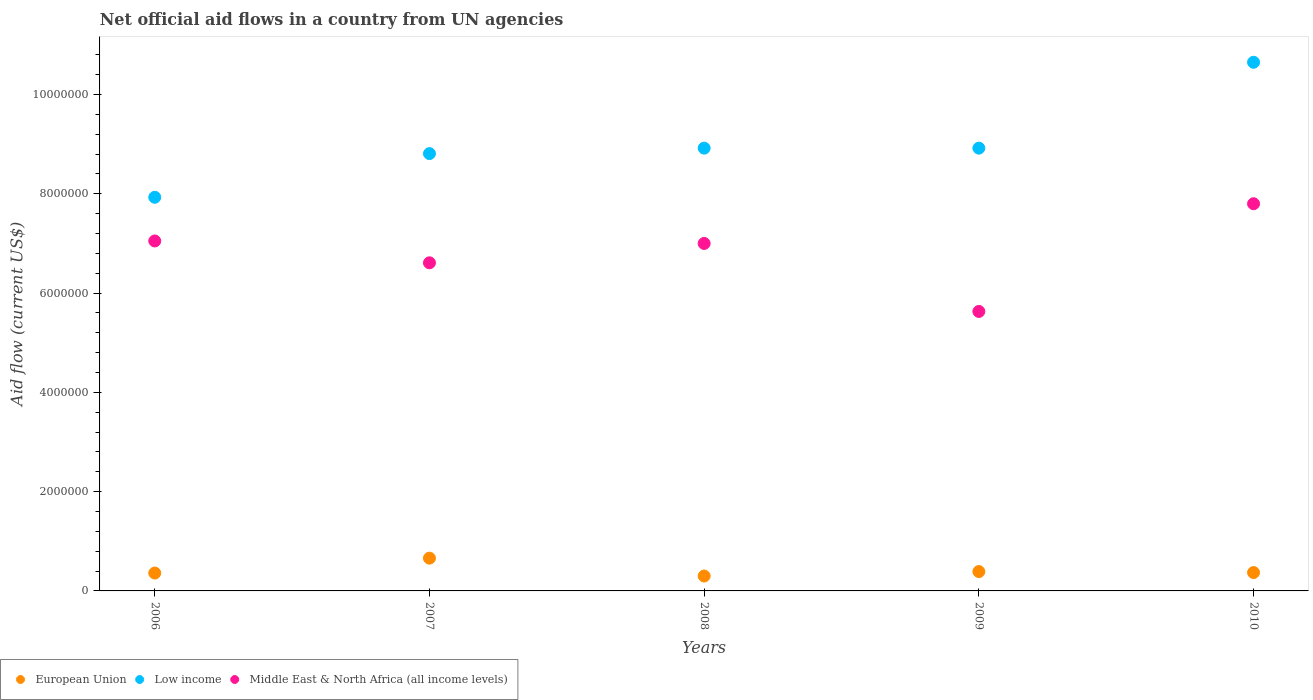How many different coloured dotlines are there?
Provide a short and direct response. 3. What is the net official aid flow in European Union in 2008?
Your answer should be very brief. 3.00e+05. Across all years, what is the minimum net official aid flow in Middle East & North Africa (all income levels)?
Offer a terse response. 5.63e+06. In which year was the net official aid flow in European Union minimum?
Your response must be concise. 2008. What is the total net official aid flow in Middle East & North Africa (all income levels) in the graph?
Give a very brief answer. 3.41e+07. What is the difference between the net official aid flow in Middle East & North Africa (all income levels) in 2006 and that in 2009?
Ensure brevity in your answer.  1.42e+06. What is the difference between the net official aid flow in Middle East & North Africa (all income levels) in 2006 and the net official aid flow in European Union in 2009?
Offer a terse response. 6.66e+06. What is the average net official aid flow in European Union per year?
Ensure brevity in your answer.  4.16e+05. In the year 2007, what is the difference between the net official aid flow in Low income and net official aid flow in Middle East & North Africa (all income levels)?
Make the answer very short. 2.20e+06. In how many years, is the net official aid flow in Low income greater than 6400000 US$?
Your response must be concise. 5. What is the ratio of the net official aid flow in Middle East & North Africa (all income levels) in 2007 to that in 2009?
Ensure brevity in your answer.  1.17. Is the net official aid flow in European Union in 2006 less than that in 2007?
Provide a succinct answer. Yes. Is the difference between the net official aid flow in Low income in 2009 and 2010 greater than the difference between the net official aid flow in Middle East & North Africa (all income levels) in 2009 and 2010?
Keep it short and to the point. Yes. What is the difference between the highest and the second highest net official aid flow in Low income?
Your answer should be very brief. 1.73e+06. What is the difference between the highest and the lowest net official aid flow in Middle East & North Africa (all income levels)?
Provide a short and direct response. 2.17e+06. Is the sum of the net official aid flow in Low income in 2006 and 2007 greater than the maximum net official aid flow in Middle East & North Africa (all income levels) across all years?
Offer a terse response. Yes. Is the net official aid flow in Middle East & North Africa (all income levels) strictly greater than the net official aid flow in Low income over the years?
Keep it short and to the point. No. How many years are there in the graph?
Offer a terse response. 5. Are the values on the major ticks of Y-axis written in scientific E-notation?
Provide a succinct answer. No. Does the graph contain any zero values?
Give a very brief answer. No. Does the graph contain grids?
Keep it short and to the point. No. How many legend labels are there?
Ensure brevity in your answer.  3. How are the legend labels stacked?
Offer a terse response. Horizontal. What is the title of the graph?
Your answer should be very brief. Net official aid flows in a country from UN agencies. What is the Aid flow (current US$) in European Union in 2006?
Provide a short and direct response. 3.60e+05. What is the Aid flow (current US$) of Low income in 2006?
Give a very brief answer. 7.93e+06. What is the Aid flow (current US$) of Middle East & North Africa (all income levels) in 2006?
Provide a succinct answer. 7.05e+06. What is the Aid flow (current US$) of European Union in 2007?
Provide a succinct answer. 6.60e+05. What is the Aid flow (current US$) of Low income in 2007?
Your response must be concise. 8.81e+06. What is the Aid flow (current US$) of Middle East & North Africa (all income levels) in 2007?
Your response must be concise. 6.61e+06. What is the Aid flow (current US$) of European Union in 2008?
Your answer should be very brief. 3.00e+05. What is the Aid flow (current US$) of Low income in 2008?
Offer a terse response. 8.92e+06. What is the Aid flow (current US$) of Low income in 2009?
Your answer should be very brief. 8.92e+06. What is the Aid flow (current US$) in Middle East & North Africa (all income levels) in 2009?
Offer a very short reply. 5.63e+06. What is the Aid flow (current US$) in European Union in 2010?
Offer a very short reply. 3.70e+05. What is the Aid flow (current US$) in Low income in 2010?
Give a very brief answer. 1.06e+07. What is the Aid flow (current US$) in Middle East & North Africa (all income levels) in 2010?
Give a very brief answer. 7.80e+06. Across all years, what is the maximum Aid flow (current US$) in Low income?
Keep it short and to the point. 1.06e+07. Across all years, what is the maximum Aid flow (current US$) of Middle East & North Africa (all income levels)?
Keep it short and to the point. 7.80e+06. Across all years, what is the minimum Aid flow (current US$) of European Union?
Offer a very short reply. 3.00e+05. Across all years, what is the minimum Aid flow (current US$) in Low income?
Your answer should be very brief. 7.93e+06. Across all years, what is the minimum Aid flow (current US$) in Middle East & North Africa (all income levels)?
Your response must be concise. 5.63e+06. What is the total Aid flow (current US$) in European Union in the graph?
Your response must be concise. 2.08e+06. What is the total Aid flow (current US$) in Low income in the graph?
Keep it short and to the point. 4.52e+07. What is the total Aid flow (current US$) of Middle East & North Africa (all income levels) in the graph?
Make the answer very short. 3.41e+07. What is the difference between the Aid flow (current US$) of Low income in 2006 and that in 2007?
Give a very brief answer. -8.80e+05. What is the difference between the Aid flow (current US$) in Middle East & North Africa (all income levels) in 2006 and that in 2007?
Provide a short and direct response. 4.40e+05. What is the difference between the Aid flow (current US$) in European Union in 2006 and that in 2008?
Offer a very short reply. 6.00e+04. What is the difference between the Aid flow (current US$) in Low income in 2006 and that in 2008?
Your response must be concise. -9.90e+05. What is the difference between the Aid flow (current US$) of Middle East & North Africa (all income levels) in 2006 and that in 2008?
Offer a very short reply. 5.00e+04. What is the difference between the Aid flow (current US$) of Low income in 2006 and that in 2009?
Your answer should be compact. -9.90e+05. What is the difference between the Aid flow (current US$) of Middle East & North Africa (all income levels) in 2006 and that in 2009?
Keep it short and to the point. 1.42e+06. What is the difference between the Aid flow (current US$) in European Union in 2006 and that in 2010?
Ensure brevity in your answer.  -10000. What is the difference between the Aid flow (current US$) of Low income in 2006 and that in 2010?
Give a very brief answer. -2.72e+06. What is the difference between the Aid flow (current US$) in Middle East & North Africa (all income levels) in 2006 and that in 2010?
Provide a succinct answer. -7.50e+05. What is the difference between the Aid flow (current US$) in Low income in 2007 and that in 2008?
Your answer should be compact. -1.10e+05. What is the difference between the Aid flow (current US$) in Middle East & North Africa (all income levels) in 2007 and that in 2008?
Your answer should be very brief. -3.90e+05. What is the difference between the Aid flow (current US$) of European Union in 2007 and that in 2009?
Offer a very short reply. 2.70e+05. What is the difference between the Aid flow (current US$) in Middle East & North Africa (all income levels) in 2007 and that in 2009?
Your answer should be very brief. 9.80e+05. What is the difference between the Aid flow (current US$) in European Union in 2007 and that in 2010?
Your answer should be compact. 2.90e+05. What is the difference between the Aid flow (current US$) of Low income in 2007 and that in 2010?
Make the answer very short. -1.84e+06. What is the difference between the Aid flow (current US$) of Middle East & North Africa (all income levels) in 2007 and that in 2010?
Ensure brevity in your answer.  -1.19e+06. What is the difference between the Aid flow (current US$) of Low income in 2008 and that in 2009?
Give a very brief answer. 0. What is the difference between the Aid flow (current US$) of Middle East & North Africa (all income levels) in 2008 and that in 2009?
Provide a short and direct response. 1.37e+06. What is the difference between the Aid flow (current US$) in Low income in 2008 and that in 2010?
Make the answer very short. -1.73e+06. What is the difference between the Aid flow (current US$) of Middle East & North Africa (all income levels) in 2008 and that in 2010?
Make the answer very short. -8.00e+05. What is the difference between the Aid flow (current US$) of Low income in 2009 and that in 2010?
Give a very brief answer. -1.73e+06. What is the difference between the Aid flow (current US$) in Middle East & North Africa (all income levels) in 2009 and that in 2010?
Offer a very short reply. -2.17e+06. What is the difference between the Aid flow (current US$) in European Union in 2006 and the Aid flow (current US$) in Low income in 2007?
Keep it short and to the point. -8.45e+06. What is the difference between the Aid flow (current US$) in European Union in 2006 and the Aid flow (current US$) in Middle East & North Africa (all income levels) in 2007?
Ensure brevity in your answer.  -6.25e+06. What is the difference between the Aid flow (current US$) of Low income in 2006 and the Aid flow (current US$) of Middle East & North Africa (all income levels) in 2007?
Offer a terse response. 1.32e+06. What is the difference between the Aid flow (current US$) of European Union in 2006 and the Aid flow (current US$) of Low income in 2008?
Provide a short and direct response. -8.56e+06. What is the difference between the Aid flow (current US$) in European Union in 2006 and the Aid flow (current US$) in Middle East & North Africa (all income levels) in 2008?
Provide a succinct answer. -6.64e+06. What is the difference between the Aid flow (current US$) in Low income in 2006 and the Aid flow (current US$) in Middle East & North Africa (all income levels) in 2008?
Offer a very short reply. 9.30e+05. What is the difference between the Aid flow (current US$) of European Union in 2006 and the Aid flow (current US$) of Low income in 2009?
Offer a very short reply. -8.56e+06. What is the difference between the Aid flow (current US$) of European Union in 2006 and the Aid flow (current US$) of Middle East & North Africa (all income levels) in 2009?
Offer a very short reply. -5.27e+06. What is the difference between the Aid flow (current US$) of Low income in 2006 and the Aid flow (current US$) of Middle East & North Africa (all income levels) in 2009?
Provide a succinct answer. 2.30e+06. What is the difference between the Aid flow (current US$) in European Union in 2006 and the Aid flow (current US$) in Low income in 2010?
Offer a terse response. -1.03e+07. What is the difference between the Aid flow (current US$) of European Union in 2006 and the Aid flow (current US$) of Middle East & North Africa (all income levels) in 2010?
Offer a very short reply. -7.44e+06. What is the difference between the Aid flow (current US$) of European Union in 2007 and the Aid flow (current US$) of Low income in 2008?
Ensure brevity in your answer.  -8.26e+06. What is the difference between the Aid flow (current US$) of European Union in 2007 and the Aid flow (current US$) of Middle East & North Africa (all income levels) in 2008?
Keep it short and to the point. -6.34e+06. What is the difference between the Aid flow (current US$) of Low income in 2007 and the Aid flow (current US$) of Middle East & North Africa (all income levels) in 2008?
Your response must be concise. 1.81e+06. What is the difference between the Aid flow (current US$) in European Union in 2007 and the Aid flow (current US$) in Low income in 2009?
Your answer should be compact. -8.26e+06. What is the difference between the Aid flow (current US$) of European Union in 2007 and the Aid flow (current US$) of Middle East & North Africa (all income levels) in 2009?
Your answer should be compact. -4.97e+06. What is the difference between the Aid flow (current US$) of Low income in 2007 and the Aid flow (current US$) of Middle East & North Africa (all income levels) in 2009?
Offer a very short reply. 3.18e+06. What is the difference between the Aid flow (current US$) of European Union in 2007 and the Aid flow (current US$) of Low income in 2010?
Give a very brief answer. -9.99e+06. What is the difference between the Aid flow (current US$) in European Union in 2007 and the Aid flow (current US$) in Middle East & North Africa (all income levels) in 2010?
Your answer should be compact. -7.14e+06. What is the difference between the Aid flow (current US$) in Low income in 2007 and the Aid flow (current US$) in Middle East & North Africa (all income levels) in 2010?
Provide a succinct answer. 1.01e+06. What is the difference between the Aid flow (current US$) of European Union in 2008 and the Aid flow (current US$) of Low income in 2009?
Keep it short and to the point. -8.62e+06. What is the difference between the Aid flow (current US$) of European Union in 2008 and the Aid flow (current US$) of Middle East & North Africa (all income levels) in 2009?
Give a very brief answer. -5.33e+06. What is the difference between the Aid flow (current US$) in Low income in 2008 and the Aid flow (current US$) in Middle East & North Africa (all income levels) in 2009?
Make the answer very short. 3.29e+06. What is the difference between the Aid flow (current US$) in European Union in 2008 and the Aid flow (current US$) in Low income in 2010?
Make the answer very short. -1.04e+07. What is the difference between the Aid flow (current US$) in European Union in 2008 and the Aid flow (current US$) in Middle East & North Africa (all income levels) in 2010?
Your answer should be compact. -7.50e+06. What is the difference between the Aid flow (current US$) of Low income in 2008 and the Aid flow (current US$) of Middle East & North Africa (all income levels) in 2010?
Provide a short and direct response. 1.12e+06. What is the difference between the Aid flow (current US$) in European Union in 2009 and the Aid flow (current US$) in Low income in 2010?
Your answer should be compact. -1.03e+07. What is the difference between the Aid flow (current US$) of European Union in 2009 and the Aid flow (current US$) of Middle East & North Africa (all income levels) in 2010?
Make the answer very short. -7.41e+06. What is the difference between the Aid flow (current US$) of Low income in 2009 and the Aid flow (current US$) of Middle East & North Africa (all income levels) in 2010?
Make the answer very short. 1.12e+06. What is the average Aid flow (current US$) in European Union per year?
Offer a terse response. 4.16e+05. What is the average Aid flow (current US$) of Low income per year?
Keep it short and to the point. 9.05e+06. What is the average Aid flow (current US$) in Middle East & North Africa (all income levels) per year?
Your response must be concise. 6.82e+06. In the year 2006, what is the difference between the Aid flow (current US$) of European Union and Aid flow (current US$) of Low income?
Ensure brevity in your answer.  -7.57e+06. In the year 2006, what is the difference between the Aid flow (current US$) of European Union and Aid flow (current US$) of Middle East & North Africa (all income levels)?
Your answer should be very brief. -6.69e+06. In the year 2006, what is the difference between the Aid flow (current US$) in Low income and Aid flow (current US$) in Middle East & North Africa (all income levels)?
Keep it short and to the point. 8.80e+05. In the year 2007, what is the difference between the Aid flow (current US$) of European Union and Aid flow (current US$) of Low income?
Your answer should be very brief. -8.15e+06. In the year 2007, what is the difference between the Aid flow (current US$) in European Union and Aid flow (current US$) in Middle East & North Africa (all income levels)?
Your answer should be compact. -5.95e+06. In the year 2007, what is the difference between the Aid flow (current US$) in Low income and Aid flow (current US$) in Middle East & North Africa (all income levels)?
Your response must be concise. 2.20e+06. In the year 2008, what is the difference between the Aid flow (current US$) in European Union and Aid flow (current US$) in Low income?
Give a very brief answer. -8.62e+06. In the year 2008, what is the difference between the Aid flow (current US$) of European Union and Aid flow (current US$) of Middle East & North Africa (all income levels)?
Provide a succinct answer. -6.70e+06. In the year 2008, what is the difference between the Aid flow (current US$) of Low income and Aid flow (current US$) of Middle East & North Africa (all income levels)?
Make the answer very short. 1.92e+06. In the year 2009, what is the difference between the Aid flow (current US$) of European Union and Aid flow (current US$) of Low income?
Provide a succinct answer. -8.53e+06. In the year 2009, what is the difference between the Aid flow (current US$) of European Union and Aid flow (current US$) of Middle East & North Africa (all income levels)?
Offer a very short reply. -5.24e+06. In the year 2009, what is the difference between the Aid flow (current US$) of Low income and Aid flow (current US$) of Middle East & North Africa (all income levels)?
Keep it short and to the point. 3.29e+06. In the year 2010, what is the difference between the Aid flow (current US$) in European Union and Aid flow (current US$) in Low income?
Make the answer very short. -1.03e+07. In the year 2010, what is the difference between the Aid flow (current US$) in European Union and Aid flow (current US$) in Middle East & North Africa (all income levels)?
Provide a short and direct response. -7.43e+06. In the year 2010, what is the difference between the Aid flow (current US$) of Low income and Aid flow (current US$) of Middle East & North Africa (all income levels)?
Offer a very short reply. 2.85e+06. What is the ratio of the Aid flow (current US$) in European Union in 2006 to that in 2007?
Your answer should be compact. 0.55. What is the ratio of the Aid flow (current US$) of Low income in 2006 to that in 2007?
Give a very brief answer. 0.9. What is the ratio of the Aid flow (current US$) in Middle East & North Africa (all income levels) in 2006 to that in 2007?
Offer a terse response. 1.07. What is the ratio of the Aid flow (current US$) in European Union in 2006 to that in 2008?
Make the answer very short. 1.2. What is the ratio of the Aid flow (current US$) in Low income in 2006 to that in 2008?
Make the answer very short. 0.89. What is the ratio of the Aid flow (current US$) of Middle East & North Africa (all income levels) in 2006 to that in 2008?
Give a very brief answer. 1.01. What is the ratio of the Aid flow (current US$) of European Union in 2006 to that in 2009?
Your answer should be very brief. 0.92. What is the ratio of the Aid flow (current US$) of Low income in 2006 to that in 2009?
Give a very brief answer. 0.89. What is the ratio of the Aid flow (current US$) of Middle East & North Africa (all income levels) in 2006 to that in 2009?
Offer a terse response. 1.25. What is the ratio of the Aid flow (current US$) of European Union in 2006 to that in 2010?
Provide a short and direct response. 0.97. What is the ratio of the Aid flow (current US$) of Low income in 2006 to that in 2010?
Provide a succinct answer. 0.74. What is the ratio of the Aid flow (current US$) in Middle East & North Africa (all income levels) in 2006 to that in 2010?
Make the answer very short. 0.9. What is the ratio of the Aid flow (current US$) in European Union in 2007 to that in 2008?
Your answer should be very brief. 2.2. What is the ratio of the Aid flow (current US$) of Low income in 2007 to that in 2008?
Give a very brief answer. 0.99. What is the ratio of the Aid flow (current US$) of Middle East & North Africa (all income levels) in 2007 to that in 2008?
Your answer should be very brief. 0.94. What is the ratio of the Aid flow (current US$) of European Union in 2007 to that in 2009?
Provide a succinct answer. 1.69. What is the ratio of the Aid flow (current US$) in Low income in 2007 to that in 2009?
Ensure brevity in your answer.  0.99. What is the ratio of the Aid flow (current US$) in Middle East & North Africa (all income levels) in 2007 to that in 2009?
Your response must be concise. 1.17. What is the ratio of the Aid flow (current US$) of European Union in 2007 to that in 2010?
Make the answer very short. 1.78. What is the ratio of the Aid flow (current US$) of Low income in 2007 to that in 2010?
Make the answer very short. 0.83. What is the ratio of the Aid flow (current US$) in Middle East & North Africa (all income levels) in 2007 to that in 2010?
Provide a succinct answer. 0.85. What is the ratio of the Aid flow (current US$) in European Union in 2008 to that in 2009?
Offer a terse response. 0.77. What is the ratio of the Aid flow (current US$) of Middle East & North Africa (all income levels) in 2008 to that in 2009?
Make the answer very short. 1.24. What is the ratio of the Aid flow (current US$) of European Union in 2008 to that in 2010?
Provide a short and direct response. 0.81. What is the ratio of the Aid flow (current US$) of Low income in 2008 to that in 2010?
Offer a terse response. 0.84. What is the ratio of the Aid flow (current US$) of Middle East & North Africa (all income levels) in 2008 to that in 2010?
Provide a short and direct response. 0.9. What is the ratio of the Aid flow (current US$) in European Union in 2009 to that in 2010?
Your answer should be very brief. 1.05. What is the ratio of the Aid flow (current US$) of Low income in 2009 to that in 2010?
Your response must be concise. 0.84. What is the ratio of the Aid flow (current US$) in Middle East & North Africa (all income levels) in 2009 to that in 2010?
Offer a very short reply. 0.72. What is the difference between the highest and the second highest Aid flow (current US$) in European Union?
Offer a very short reply. 2.70e+05. What is the difference between the highest and the second highest Aid flow (current US$) in Low income?
Ensure brevity in your answer.  1.73e+06. What is the difference between the highest and the second highest Aid flow (current US$) in Middle East & North Africa (all income levels)?
Keep it short and to the point. 7.50e+05. What is the difference between the highest and the lowest Aid flow (current US$) of European Union?
Give a very brief answer. 3.60e+05. What is the difference between the highest and the lowest Aid flow (current US$) in Low income?
Provide a succinct answer. 2.72e+06. What is the difference between the highest and the lowest Aid flow (current US$) in Middle East & North Africa (all income levels)?
Provide a succinct answer. 2.17e+06. 